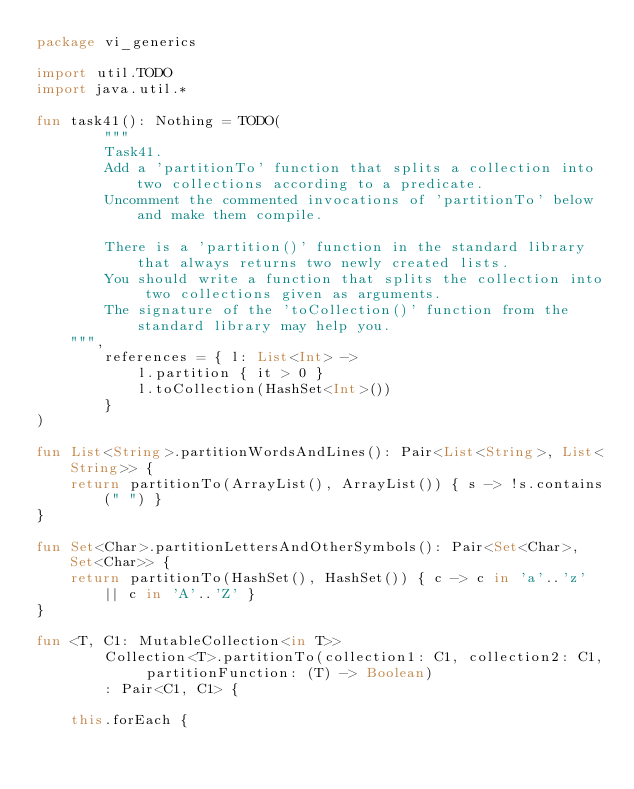Convert code to text. <code><loc_0><loc_0><loc_500><loc_500><_Kotlin_>package vi_generics

import util.TODO
import java.util.*

fun task41(): Nothing = TODO(
        """
        Task41.
        Add a 'partitionTo' function that splits a collection into two collections according to a predicate.
        Uncomment the commented invocations of 'partitionTo' below and make them compile.

        There is a 'partition()' function in the standard library that always returns two newly created lists.
        You should write a function that splits the collection into two collections given as arguments.
        The signature of the 'toCollection()' function from the standard library may help you.
    """,
        references = { l: List<Int> ->
            l.partition { it > 0 }
            l.toCollection(HashSet<Int>())
        }
)

fun List<String>.partitionWordsAndLines(): Pair<List<String>, List<String>> {
    return partitionTo(ArrayList(), ArrayList()) { s -> !s.contains(" ") }
}

fun Set<Char>.partitionLettersAndOtherSymbols(): Pair<Set<Char>, Set<Char>> {
    return partitionTo(HashSet(), HashSet()) { c -> c in 'a'..'z' || c in 'A'..'Z' }
}

fun <T, C1: MutableCollection<in T>>
        Collection<T>.partitionTo(collection1: C1, collection2: C1, partitionFunction: (T) -> Boolean)
        : Pair<C1, C1> {

    this.forEach {</code> 